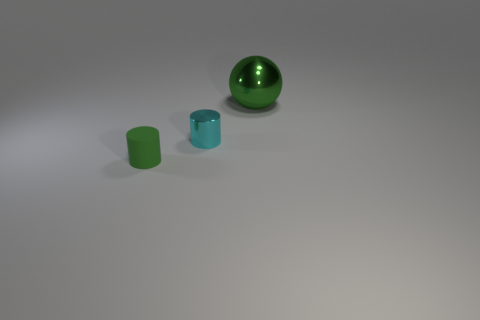There is a thing that is the same color as the small rubber cylinder; what is it made of?
Your answer should be very brief. Metal. Is the number of green metal balls on the left side of the large ball less than the number of big things that are right of the small green rubber thing?
Keep it short and to the point. Yes. What number of objects are small red matte blocks or metal things in front of the big sphere?
Provide a short and direct response. 1. What is the material of the green cylinder that is the same size as the cyan object?
Your response must be concise. Rubber. Is the material of the sphere the same as the cyan cylinder?
Give a very brief answer. Yes. What is the color of the object that is behind the tiny rubber thing and in front of the green metal thing?
Make the answer very short. Cyan. Do the thing left of the small metallic cylinder and the big shiny thing have the same color?
Offer a very short reply. Yes. There is a green rubber object that is the same size as the cyan shiny object; what shape is it?
Your response must be concise. Cylinder. What number of other things are the same color as the small metal cylinder?
Offer a terse response. 0. How many other things are there of the same material as the large sphere?
Keep it short and to the point. 1. 